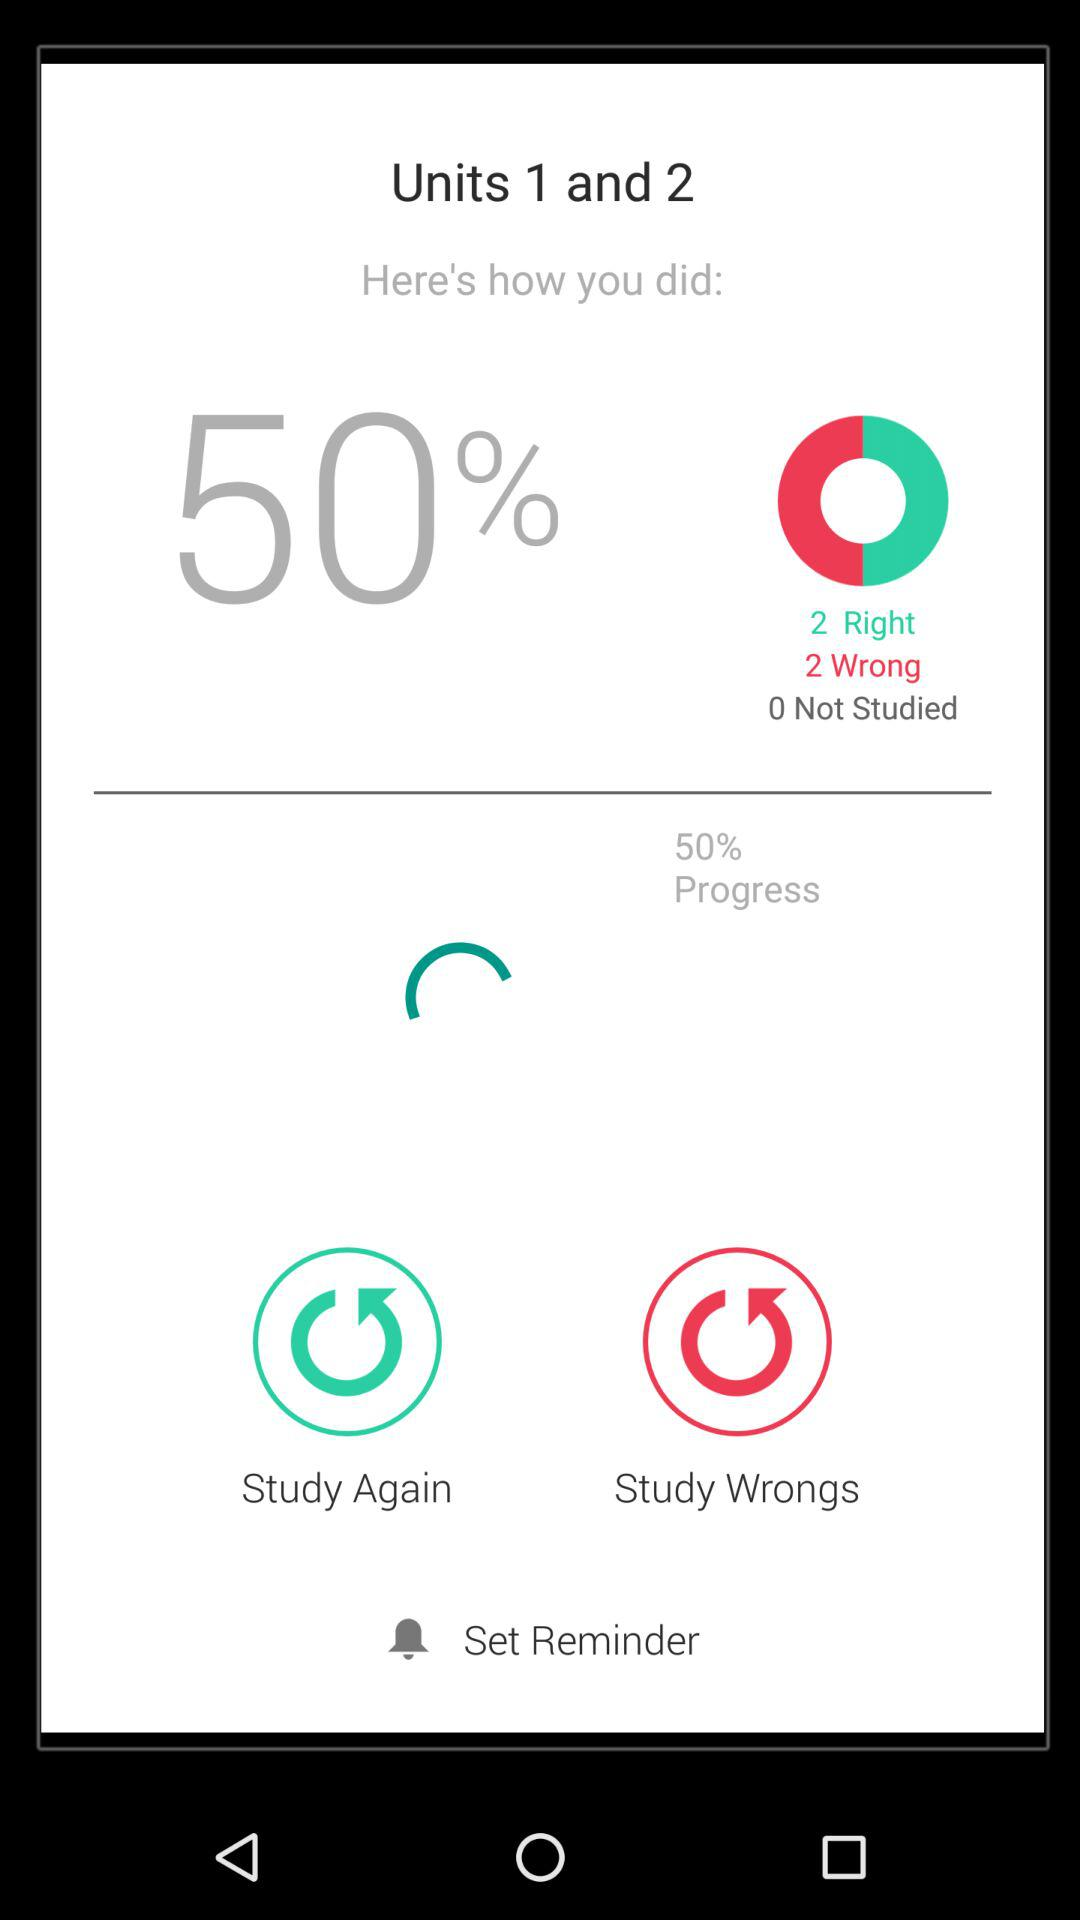How many units are covered in the assessment?
Answer the question using a single word or phrase. 2 